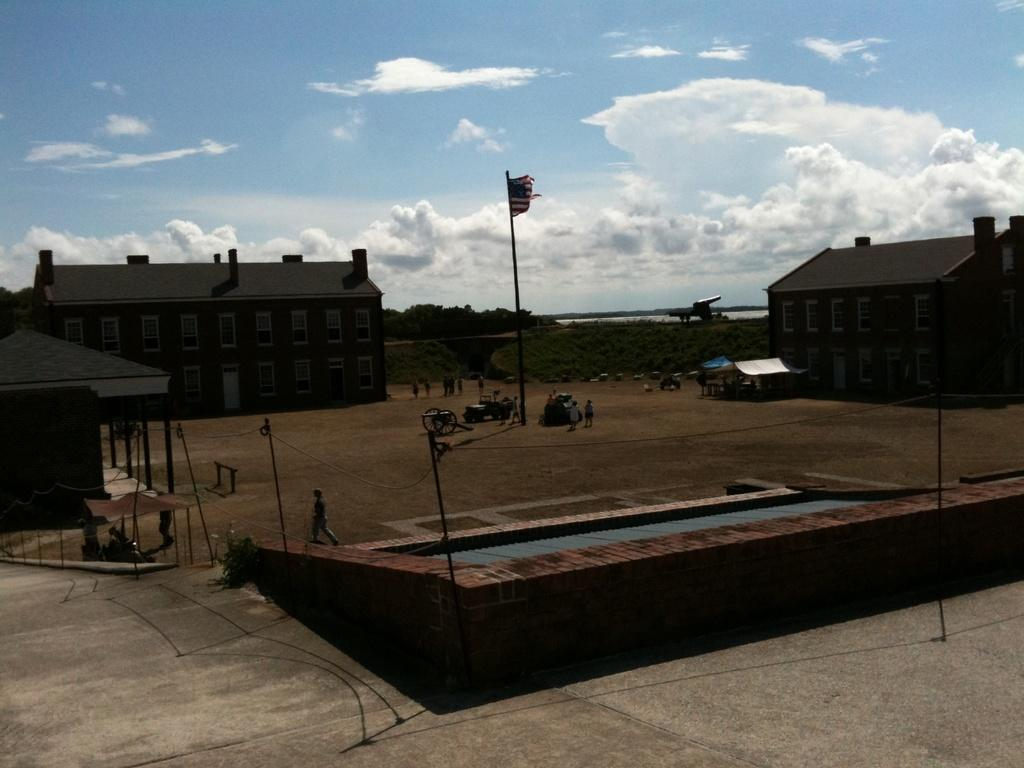What is located in the center of the image? There are poles in the center of the image. What can be seen near the poles? There are persons near the poles. What is attached to the poles? There is a flag in the image. What is visible in the background of the image? There are buildings and trees in the background of the image. How would you describe the sky in the image? The sky is cloudy in the image. How long does the earthquake last in the image? There is no earthquake present in the image. What type of canvas is used to create the flag in the image? There is no information about the type of canvas used for the flag in the image. 